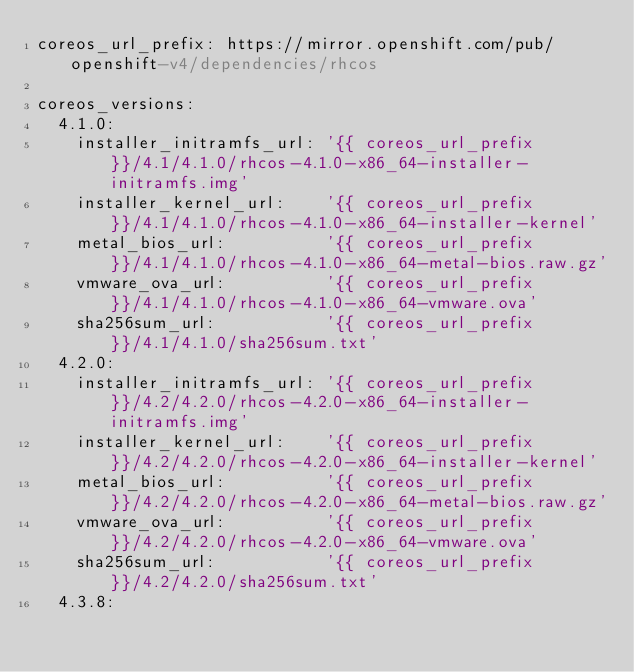<code> <loc_0><loc_0><loc_500><loc_500><_YAML_>coreos_url_prefix: https://mirror.openshift.com/pub/openshift-v4/dependencies/rhcos

coreos_versions:
  4.1.0:
    installer_initramfs_url: '{{ coreos_url_prefix }}/4.1/4.1.0/rhcos-4.1.0-x86_64-installer-initramfs.img'
    installer_kernel_url:    '{{ coreos_url_prefix }}/4.1/4.1.0/rhcos-4.1.0-x86_64-installer-kernel'
    metal_bios_url:          '{{ coreos_url_prefix }}/4.1/4.1.0/rhcos-4.1.0-x86_64-metal-bios.raw.gz'
    vmware_ova_url:          '{{ coreos_url_prefix }}/4.1/4.1.0/rhcos-4.1.0-x86_64-vmware.ova'
    sha256sum_url:           '{{ coreos_url_prefix }}/4.1/4.1.0/sha256sum.txt'
  4.2.0:
    installer_initramfs_url: '{{ coreos_url_prefix }}/4.2/4.2.0/rhcos-4.2.0-x86_64-installer-initramfs.img'
    installer_kernel_url:    '{{ coreos_url_prefix }}/4.2/4.2.0/rhcos-4.2.0-x86_64-installer-kernel'
    metal_bios_url:          '{{ coreos_url_prefix }}/4.2/4.2.0/rhcos-4.2.0-x86_64-metal-bios.raw.gz'
    vmware_ova_url:          '{{ coreos_url_prefix }}/4.2/4.2.0/rhcos-4.2.0-x86_64-vmware.ova'
    sha256sum_url:           '{{ coreos_url_prefix }}/4.2/4.2.0/sha256sum.txt'
  4.3.8:</code> 